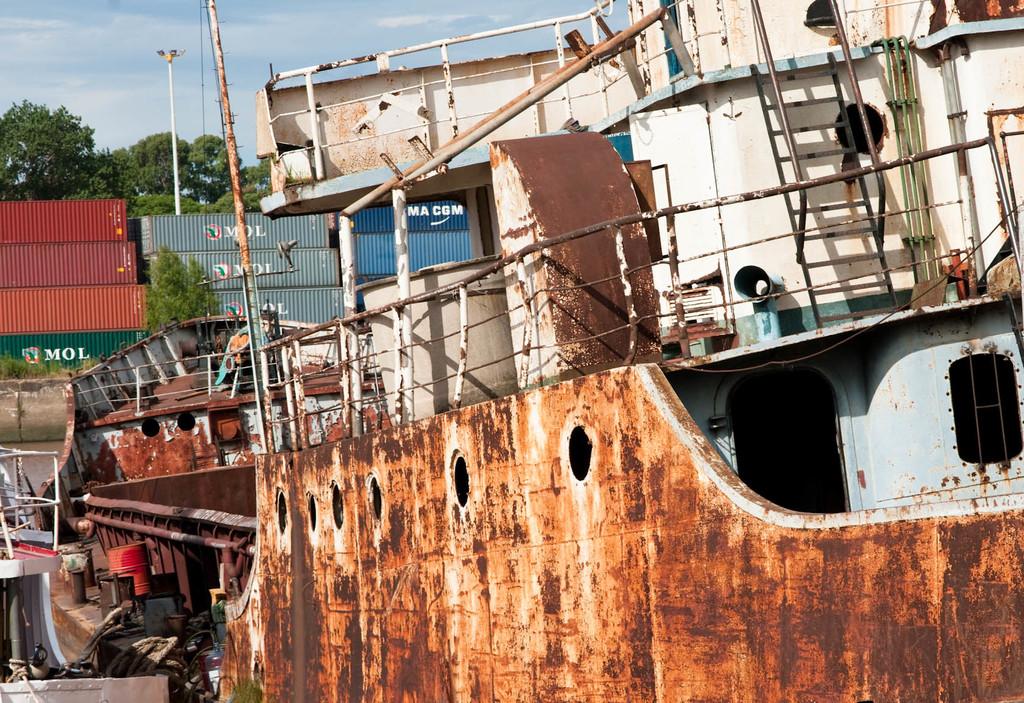What company are those storage units from?
Your answer should be compact. Mol. 